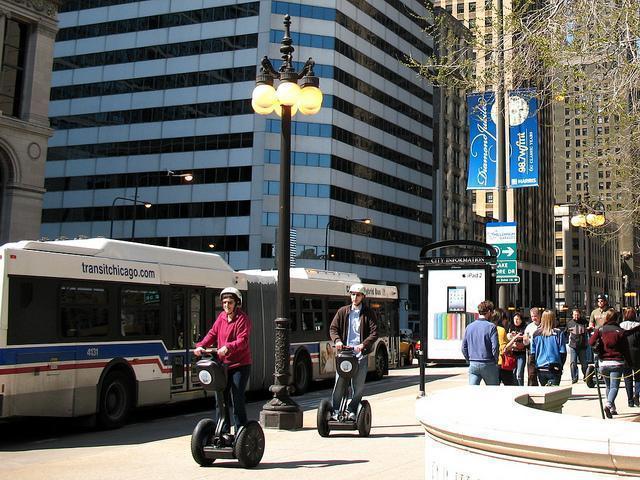Why are the the two riders wearing helmets?
Pick the correct solution from the four options below to address the question.
Options: Identification, protect heads, fashion, incognito. Protect heads. 